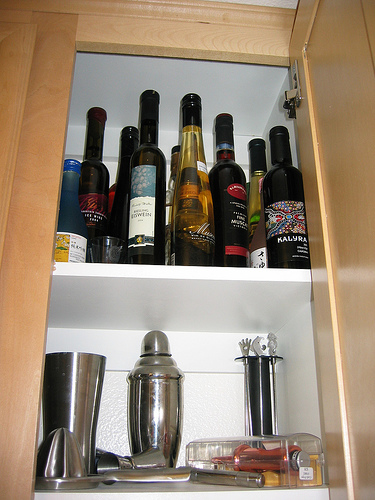<image>
Can you confirm if the liquor is in the cabinet? Yes. The liquor is contained within or inside the cabinet, showing a containment relationship. 